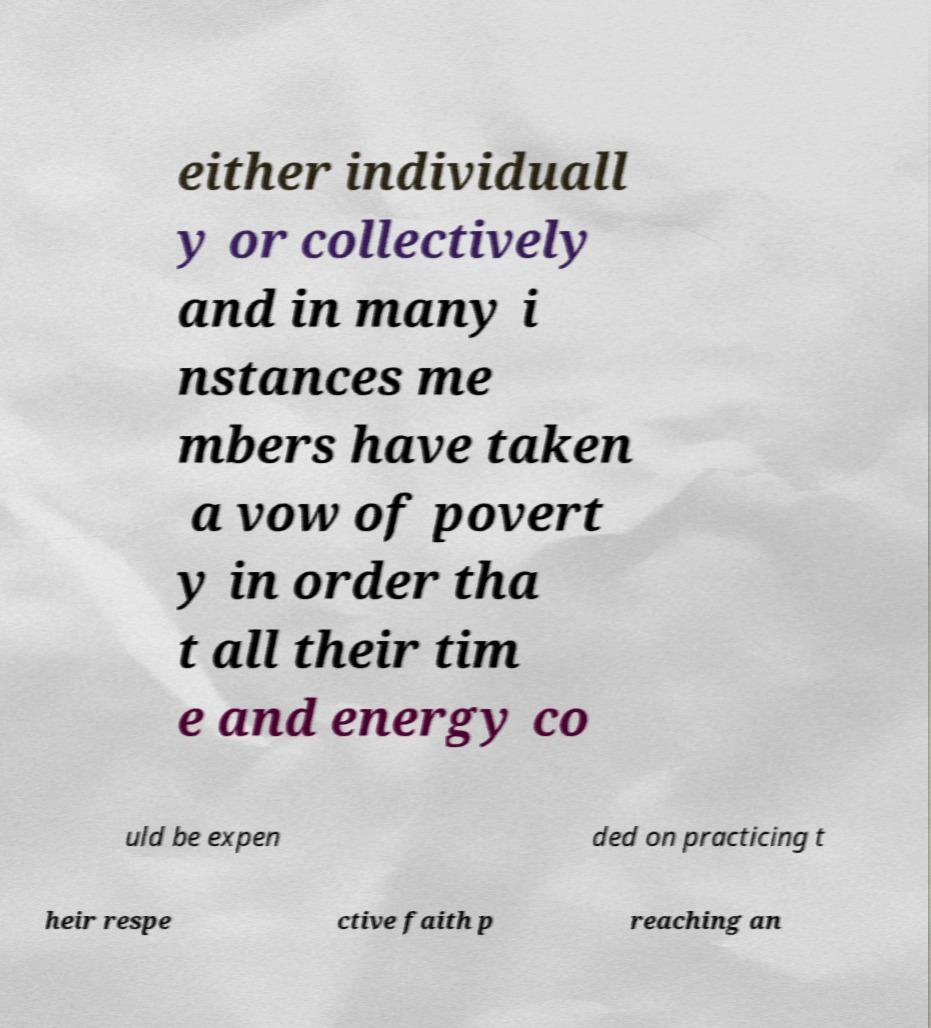What messages or text are displayed in this image? I need them in a readable, typed format. either individuall y or collectively and in many i nstances me mbers have taken a vow of povert y in order tha t all their tim e and energy co uld be expen ded on practicing t heir respe ctive faith p reaching an 